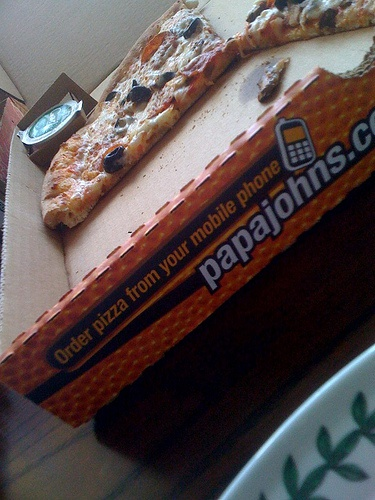Describe the objects in this image and their specific colors. I can see dining table in black, maroon, darkgray, gray, and lightgray tones and pizza in gray, darkgray, and maroon tones in this image. 